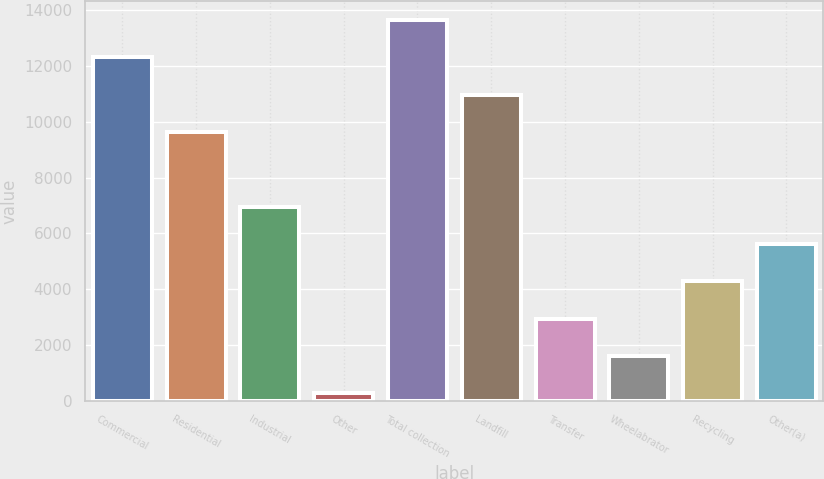<chart> <loc_0><loc_0><loc_500><loc_500><bar_chart><fcel>Commercial<fcel>Residential<fcel>Industrial<fcel>Other<fcel>Total collection<fcel>Landfill<fcel>Transfer<fcel>Wheelabrator<fcel>Recycling<fcel>Other(a)<nl><fcel>12311.6<fcel>9636.8<fcel>6962<fcel>275<fcel>13649<fcel>10974.2<fcel>2949.8<fcel>1612.4<fcel>4287.2<fcel>5624.6<nl></chart> 